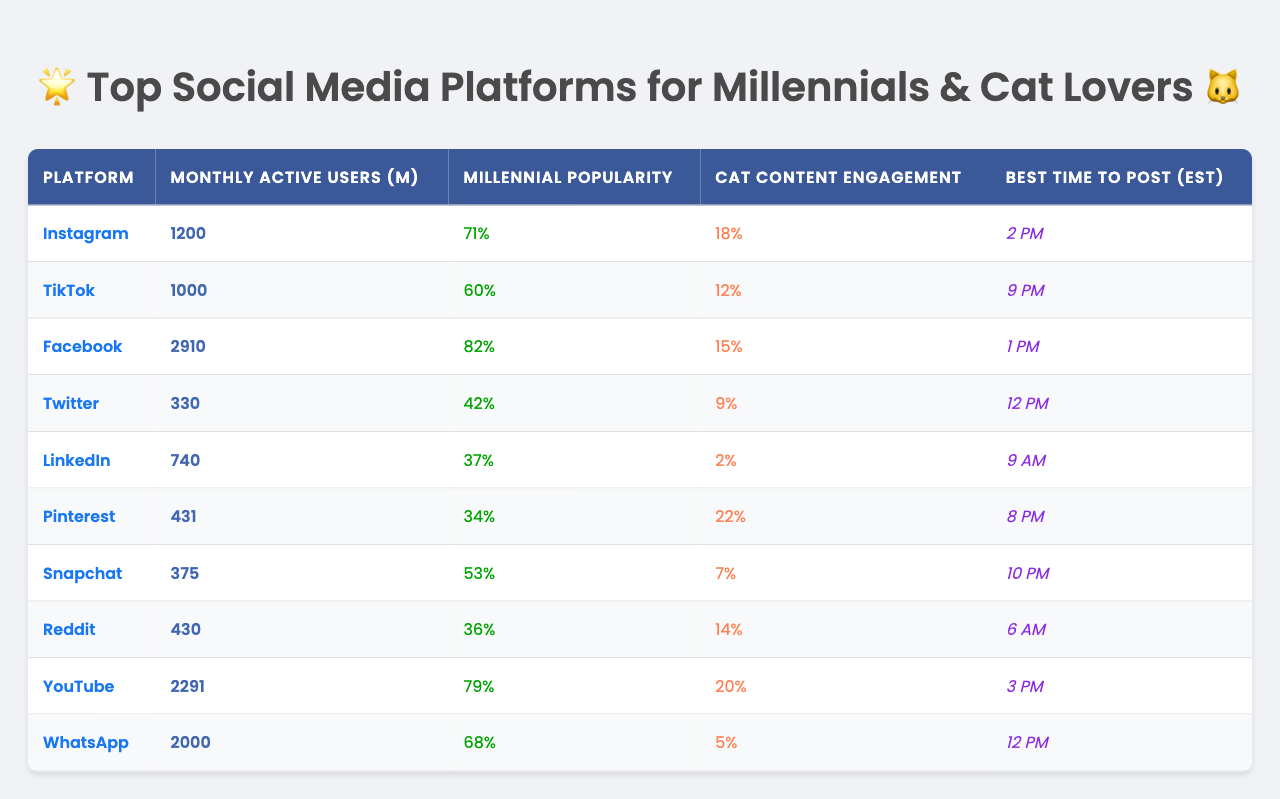What is the monthly active user count for YouTube? The table lists YouTube under the "Social Media Platform" column, and the corresponding "Monthly Active Users (Millions)" shows 2291 million users.
Answer: 2291 million Which platform has the highest engagement with cat-related content? By checking the "Cat-Related Content Engagement (%)" column, Pinterest shows the highest engagement at 22%.
Answer: 22% How many platforms have more than 1000 million active users? From the "Monthly Active Users (Millions)" column, Facebook (2910 million), WhatsApp (2000 million), and Instagram (1200 million) are identified, totaling 3 platforms.
Answer: 3 What percentage of users on LinkedIn are millennials? The "Popular with Millennials (%)" column shows that 37% of LinkedIn users are millennials.
Answer: 37% Is TikTok more popular among millennials than Twitter? Checking the respective values in the "Popular with Millennials (%)" column, TikTok has 60% while Twitter has 42%, confirming TikTok is more popular among millennials.
Answer: Yes What is the difference in active users between Facebook and WhatsApp? Facebook has 2910 million active users and WhatsApp has 2000 million users. The difference is 2910 - 2000 = 910 million.
Answer: 910 million What is the best time to post on Instagram? Referring to the "Best Time to Post (EST)" column for Instagram, it shows that the best time to post is 2 PM.
Answer: 2 PM What is the average percentage of cat-related content engagement across all platforms? Summing up the values from the "Cat-Related Content Engagement (%)" column gives 18 + 12 + 15 + 9 + 2 + 22 + 7 + 14 + 20 + 5 = 124. There are 10 platforms, so the average is 124 / 10 = 12.4%.
Answer: 12.4% Which platform has the least popularity among millennials? By looking at the "Popular with Millennials (%)" column, Pinterest has the lowest value at 34%.
Answer: 34% How many platforms have a monthly active user count of less than 500 million? Reviewing the "Monthly Active Users (Millions)" column, only Snapchat (375 million) and Reddit (430 million) have counts below 500 million, totaling 2 platforms.
Answer: 2 